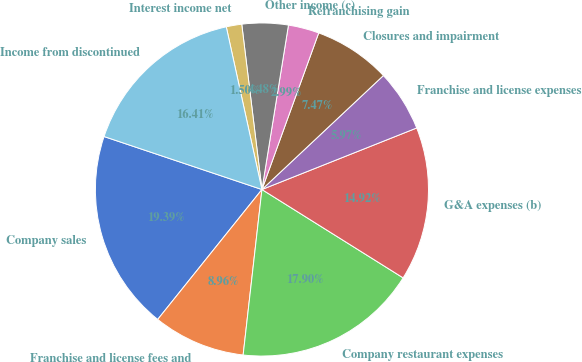Convert chart. <chart><loc_0><loc_0><loc_500><loc_500><pie_chart><fcel>Company sales<fcel>Franchise and license fees and<fcel>Company restaurant expenses<fcel>G&A expenses (b)<fcel>Franchise and license expenses<fcel>Closures and impairment<fcel>Refranchising gain<fcel>Other income (c)<fcel>Interest income net<fcel>Income from discontinued<nl><fcel>19.39%<fcel>8.96%<fcel>17.9%<fcel>14.92%<fcel>5.97%<fcel>7.47%<fcel>2.99%<fcel>4.48%<fcel>1.5%<fcel>16.41%<nl></chart> 